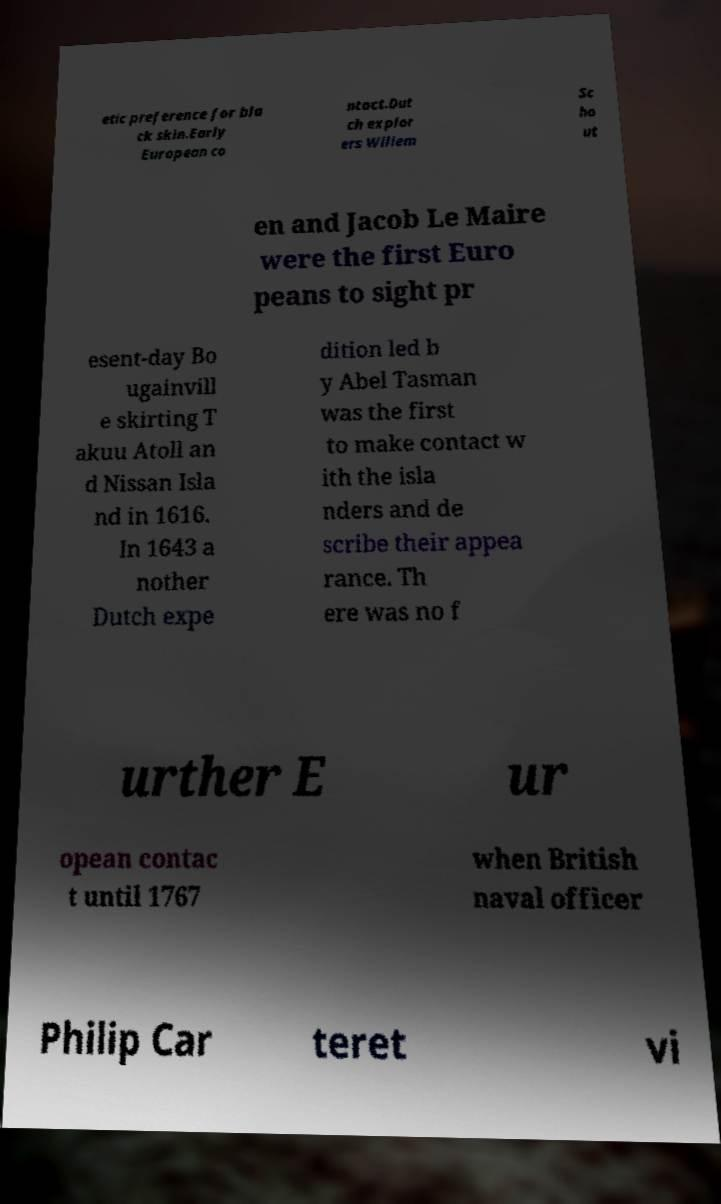Could you assist in decoding the text presented in this image and type it out clearly? etic preference for bla ck skin.Early European co ntact.Dut ch explor ers Willem Sc ho ut en and Jacob Le Maire were the first Euro peans to sight pr esent-day Bo ugainvill e skirting T akuu Atoll an d Nissan Isla nd in 1616. In 1643 a nother Dutch expe dition led b y Abel Tasman was the first to make contact w ith the isla nders and de scribe their appea rance. Th ere was no f urther E ur opean contac t until 1767 when British naval officer Philip Car teret vi 